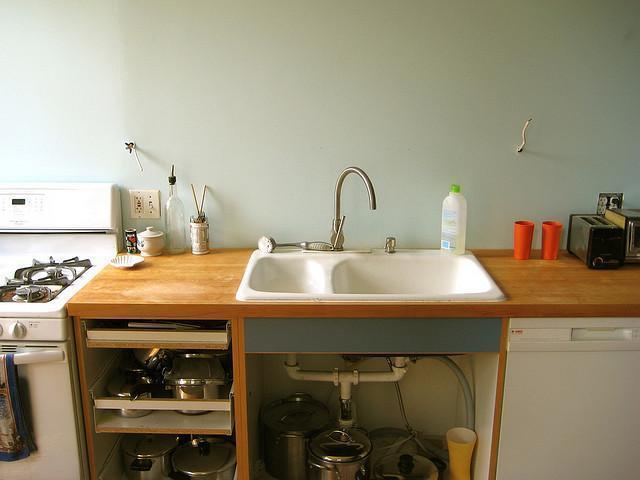What would someone most likely clean in this room?
Choose the right answer from the provided options to respond to the question.
Options: Clothes, body, dishes, car. Dishes. 